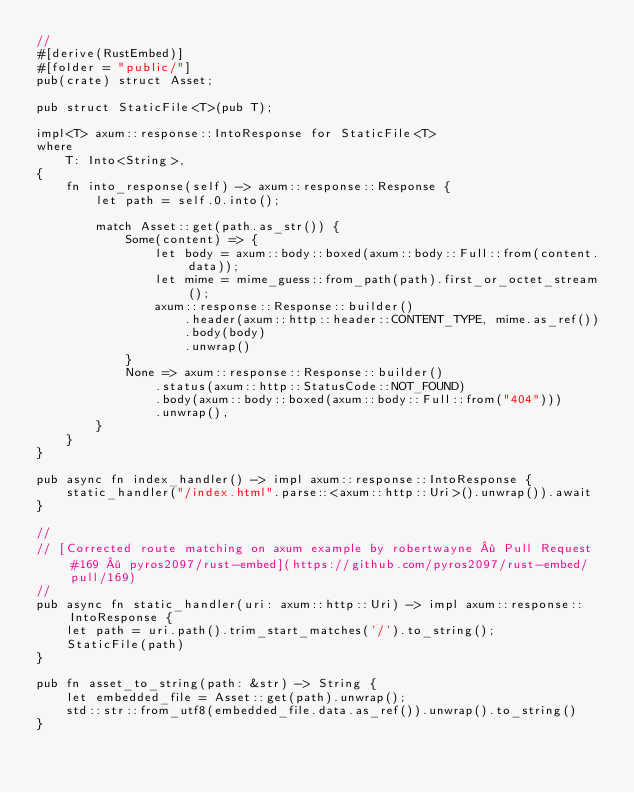Convert code to text. <code><loc_0><loc_0><loc_500><loc_500><_Rust_>//
#[derive(RustEmbed)]
#[folder = "public/"]
pub(crate) struct Asset;

pub struct StaticFile<T>(pub T);

impl<T> axum::response::IntoResponse for StaticFile<T>
where
    T: Into<String>,
{
    fn into_response(self) -> axum::response::Response {
        let path = self.0.into();

        match Asset::get(path.as_str()) {
            Some(content) => {
                let body = axum::body::boxed(axum::body::Full::from(content.data));
                let mime = mime_guess::from_path(path).first_or_octet_stream();
                axum::response::Response::builder()
                    .header(axum::http::header::CONTENT_TYPE, mime.as_ref())
                    .body(body)
                    .unwrap()
            }
            None => axum::response::Response::builder()
                .status(axum::http::StatusCode::NOT_FOUND)
                .body(axum::body::boxed(axum::body::Full::from("404")))
                .unwrap(),
        }
    }
}

pub async fn index_handler() -> impl axum::response::IntoResponse {
    static_handler("/index.html".parse::<axum::http::Uri>().unwrap()).await
}

//
// [Corrected route matching on axum example by robertwayne · Pull Request #169 · pyros2097/rust-embed](https://github.com/pyros2097/rust-embed/pull/169)
//
pub async fn static_handler(uri: axum::http::Uri) -> impl axum::response::IntoResponse {
    let path = uri.path().trim_start_matches('/').to_string();
    StaticFile(path)
}

pub fn asset_to_string(path: &str) -> String {
    let embedded_file = Asset::get(path).unwrap();
    std::str::from_utf8(embedded_file.data.as_ref()).unwrap().to_string()
}</code> 